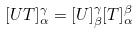<formula> <loc_0><loc_0><loc_500><loc_500>[ U T ] _ { \alpha } ^ { \gamma } = [ U ] _ { \beta } ^ { \gamma } [ T ] _ { \alpha } ^ { \beta }</formula> 